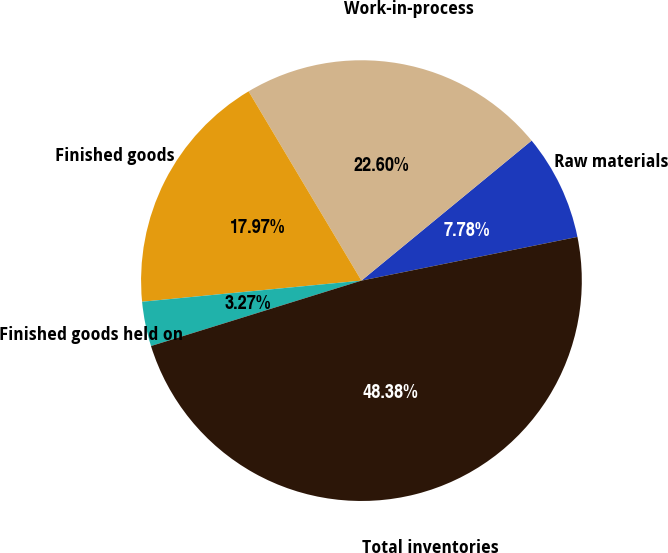<chart> <loc_0><loc_0><loc_500><loc_500><pie_chart><fcel>Raw materials<fcel>Work-in-process<fcel>Finished goods<fcel>Finished goods held on<fcel>Total inventories<nl><fcel>7.78%<fcel>22.6%<fcel>17.97%<fcel>3.27%<fcel>48.38%<nl></chart> 